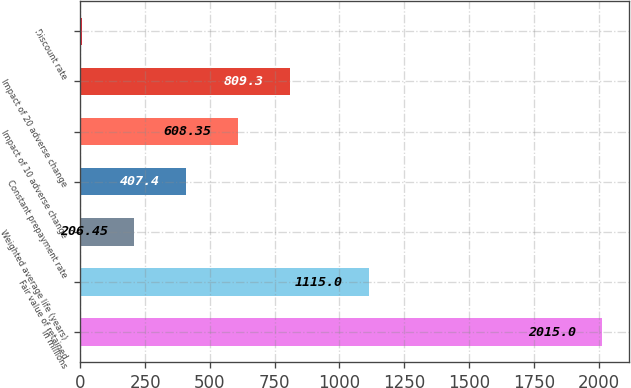Convert chart to OTSL. <chart><loc_0><loc_0><loc_500><loc_500><bar_chart><fcel>in millions<fcel>Fair value of retained<fcel>Weighted average life (years)<fcel>Constant prepayment rate<fcel>Impact of 10 adverse change<fcel>Impact of 20 adverse change<fcel>Discount rate<nl><fcel>2015<fcel>1115<fcel>206.45<fcel>407.4<fcel>608.35<fcel>809.3<fcel>5.5<nl></chart> 